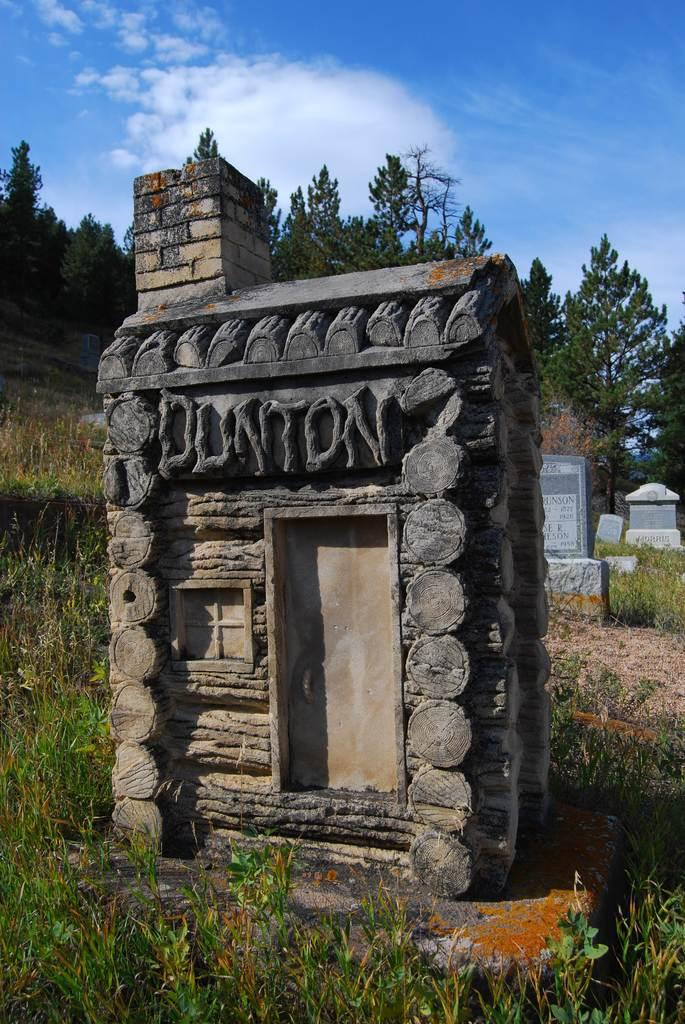<image>
Describe the image concisely. a small house with the name 'Dunton' etched into the top of it 